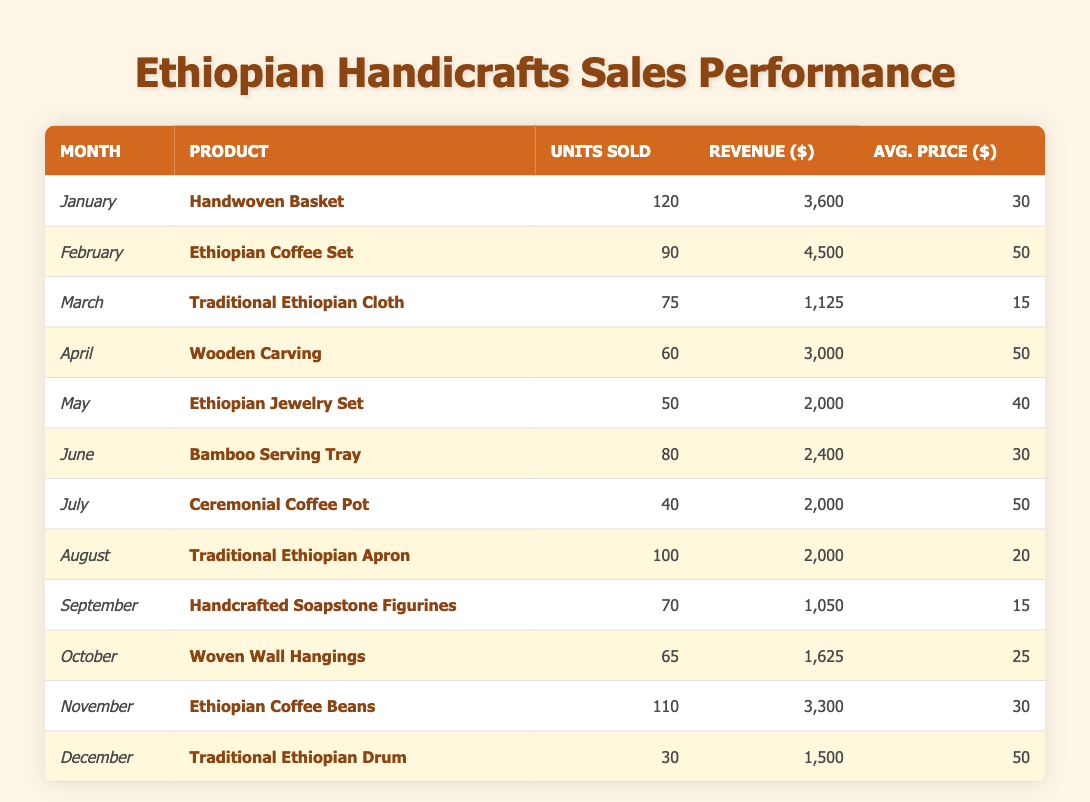What was the total revenue generated from the "Handwoven Basket" in January? In January, the revenue generated from the "Handwoven Basket" is listed as 3,600. Therefore, the total revenue is simply this value, as it pertains to that specific product and month.
Answer: 3600 Which month had the highest sales in terms of units sold? By inspecting the "Units Sold" column, January has 120 units sold (Handwoven Basket), and February has 90 units sold (Ethiopian Coffee Set) which is the next highest. Since 120 is greater than any other month's units sold, January is the month with the highest sales.
Answer: January What is the average price of the "Traditional Ethiopian Cloth"? The average price per unit of the "Traditional Ethiopian Cloth" is listed under the "Avg. Price" column as 15. Thus, we can directly retrieve this value from the table, confirming it as the average price.
Answer: 15 What is the total revenue for the "Ethiopian Jewelry Set" and "Bamboo Serving Tray" combined? The revenue for the Ethiopian Jewelry Set is 2,000, and the revenue for the Bamboo Serving Tray is 2,400. Adding these together (2,000 + 2,400) results in a total revenue of 4,400 for these two products combined.
Answer: 4400 Did the "Traditional Ethiopian Drum" generate more revenue than the "Woven Wall Hangings"? The revenue from the "Traditional Ethiopian Drum" is 1,500, whereas the "Woven Wall Hangings" revenue is 1,625. Comparing these numbers, since 1,500 is less than 1,625, the answer is no; the Traditional Ethiopian Drum did not generate more revenue.
Answer: No What was the average number of units sold for all products across the year? To find the average, we first add all units sold: 120 + 90 + 75 + 60 + 50 + 80 + 40 + 100 + 70 + 65 + 110 + 30 = 1,020. Since there are 12 months, we divide 1,020 by 12, resulting in an average of 85 units sold per month across all products.
Answer: 85 Which product had the lowest units sold and how many were sold? By inspecting the "Units Sold" column for the products, the "Traditional Ethiopian Drum" with 30 units sold is the lowest figure. Therefore, that is the product with the least sales.
Answer: Traditional Ethiopian Drum, 30 How much more revenue did the "Ethiopian Coffee Set" generate compared to the "Ceremonial Coffee Pot"? The revenue for the "Ethiopian Coffee Set" is 4,500, while the "Ceremonial Coffee Pot" generated 2,000. To find the difference, we subtract: 4,500 - 2,000 = 2,500. Thus, the "Ethiopian Coffee Set" generated 2,500 more in revenue.
Answer: 2500 